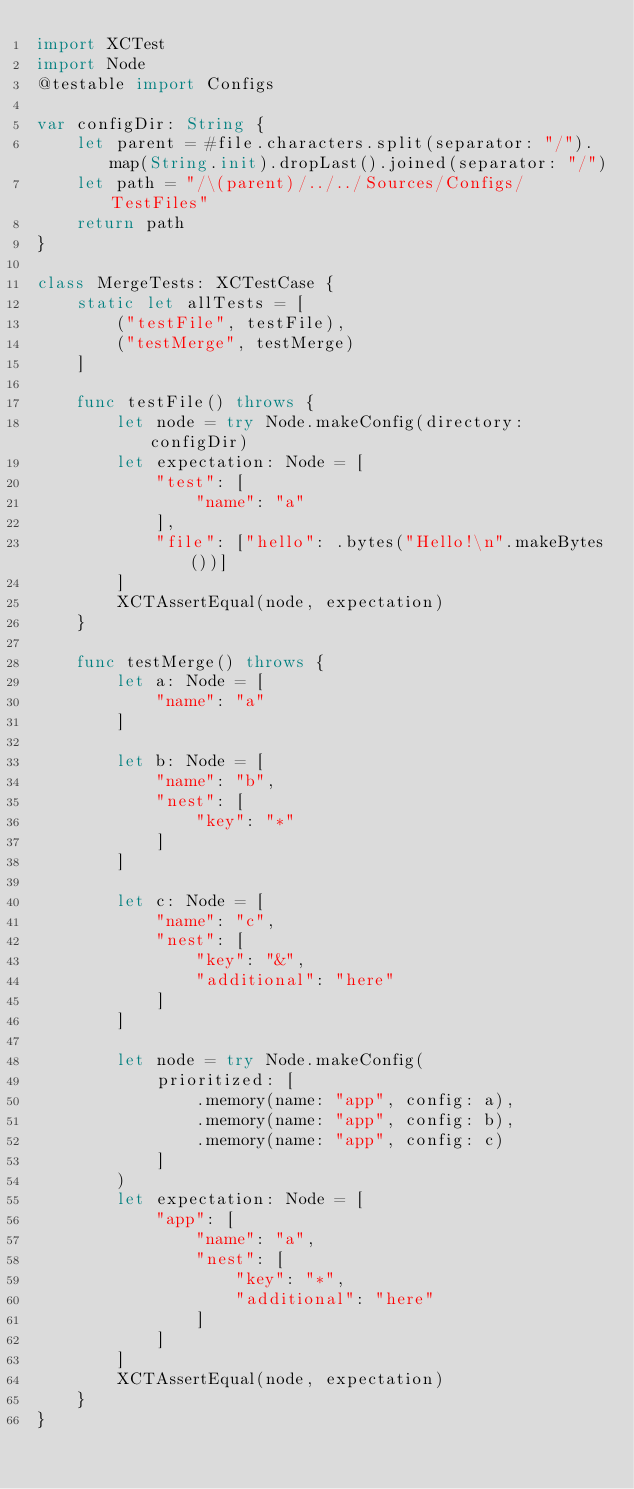<code> <loc_0><loc_0><loc_500><loc_500><_Swift_>import XCTest
import Node
@testable import Configs

var configDir: String {
    let parent = #file.characters.split(separator: "/").map(String.init).dropLast().joined(separator: "/")
    let path = "/\(parent)/../../Sources/Configs/TestFiles"
    return path
}

class MergeTests: XCTestCase {
    static let allTests = [
        ("testFile", testFile),
        ("testMerge", testMerge)
    ]
    
    func testFile() throws {
        let node = try Node.makeConfig(directory: configDir)
        let expectation: Node = [
            "test": [
                "name": "a"
            ],
            "file": ["hello": .bytes("Hello!\n".makeBytes())]
        ]
        XCTAssertEqual(node, expectation)
    }

    func testMerge() throws {
        let a: Node = [
            "name": "a"
        ]

        let b: Node = [
            "name": "b",
            "nest": [
                "key": "*"
            ]
        ]

        let c: Node = [
            "name": "c",
            "nest": [
                "key": "&",
                "additional": "here"
            ]
        ]

        let node = try Node.makeConfig(
            prioritized: [
                .memory(name: "app", config: a),
                .memory(name: "app", config: b),
                .memory(name: "app", config: c)
            ]
        )
        let expectation: Node = [
            "app": [
                "name": "a",
                "nest": [
                    "key": "*",
                    "additional": "here"
                ]
            ]
        ]
        XCTAssertEqual(node, expectation)
    }
}
</code> 